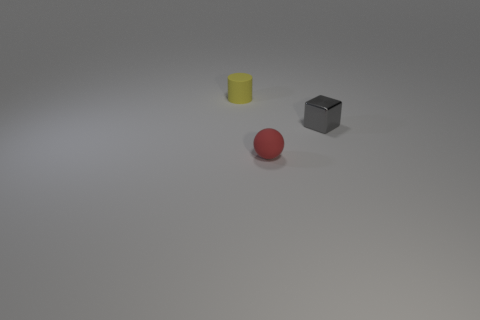There is a yellow rubber object; is its size the same as the matte thing in front of the yellow object? The yellow rubber object appears to be slightly larger in height when compared to the matte gray cube in front of it, although their sizes are relatively close. Both objects share simple geometric shapes but differ in texture and color. 